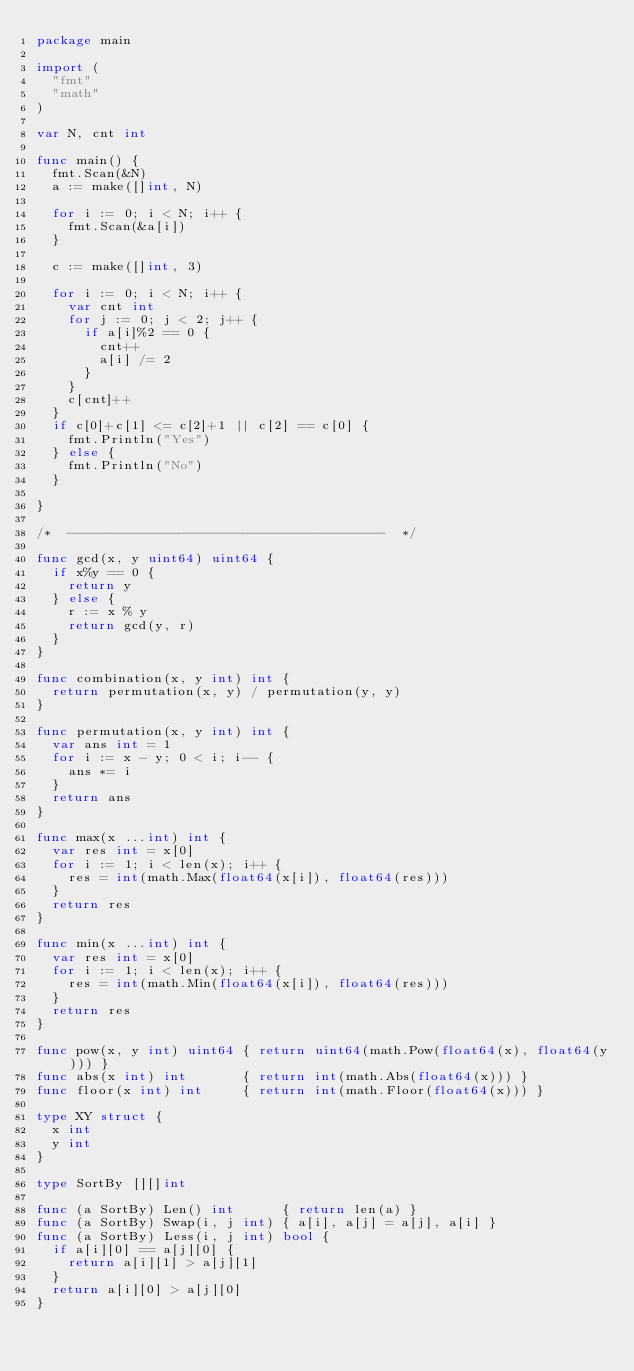Convert code to text. <code><loc_0><loc_0><loc_500><loc_500><_Go_>package main

import (
	"fmt"
	"math"
)

var N, cnt int

func main() {
	fmt.Scan(&N)
	a := make([]int, N)

	for i := 0; i < N; i++ {
		fmt.Scan(&a[i])
	}

	c := make([]int, 3)

	for i := 0; i < N; i++ {
		var cnt int
		for j := 0; j < 2; j++ {
			if a[i]%2 == 0 {
				cnt++
				a[i] /= 2
			}
		}
		c[cnt]++
	}
	if c[0]+c[1] <= c[2]+1 || c[2] == c[0] {
		fmt.Println("Yes")
	} else {
		fmt.Println("No")
	}

}

/*  ----------------------------------------  */

func gcd(x, y uint64) uint64 {
	if x%y == 0 {
		return y
	} else {
		r := x % y
		return gcd(y, r)
	}
}

func combination(x, y int) int {
	return permutation(x, y) / permutation(y, y)
}

func permutation(x, y int) int {
	var ans int = 1
	for i := x - y; 0 < i; i-- {
		ans *= i
	}
	return ans
}

func max(x ...int) int {
	var res int = x[0]
	for i := 1; i < len(x); i++ {
		res = int(math.Max(float64(x[i]), float64(res)))
	}
	return res
}

func min(x ...int) int {
	var res int = x[0]
	for i := 1; i < len(x); i++ {
		res = int(math.Min(float64(x[i]), float64(res)))
	}
	return res
}

func pow(x, y int) uint64 { return uint64(math.Pow(float64(x), float64(y))) }
func abs(x int) int       { return int(math.Abs(float64(x))) }
func floor(x int) int     { return int(math.Floor(float64(x))) }

type XY struct {
	x int
	y int
}

type SortBy [][]int

func (a SortBy) Len() int      { return len(a) }
func (a SortBy) Swap(i, j int) { a[i], a[j] = a[j], a[i] }
func (a SortBy) Less(i, j int) bool {
	if a[i][0] == a[j][0] {
		return a[i][1] > a[j][1]
	}
	return a[i][0] > a[j][0]
}
</code> 